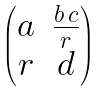<formula> <loc_0><loc_0><loc_500><loc_500>\begin{pmatrix} a & \frac { b \, c } { r } \\ r & d \end{pmatrix}</formula> 